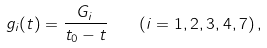<formula> <loc_0><loc_0><loc_500><loc_500>g _ { i } ( t ) = \frac { G _ { i } } { t _ { 0 } - t } \quad ( i = 1 , 2 , 3 , 4 , 7 ) \, ,</formula> 